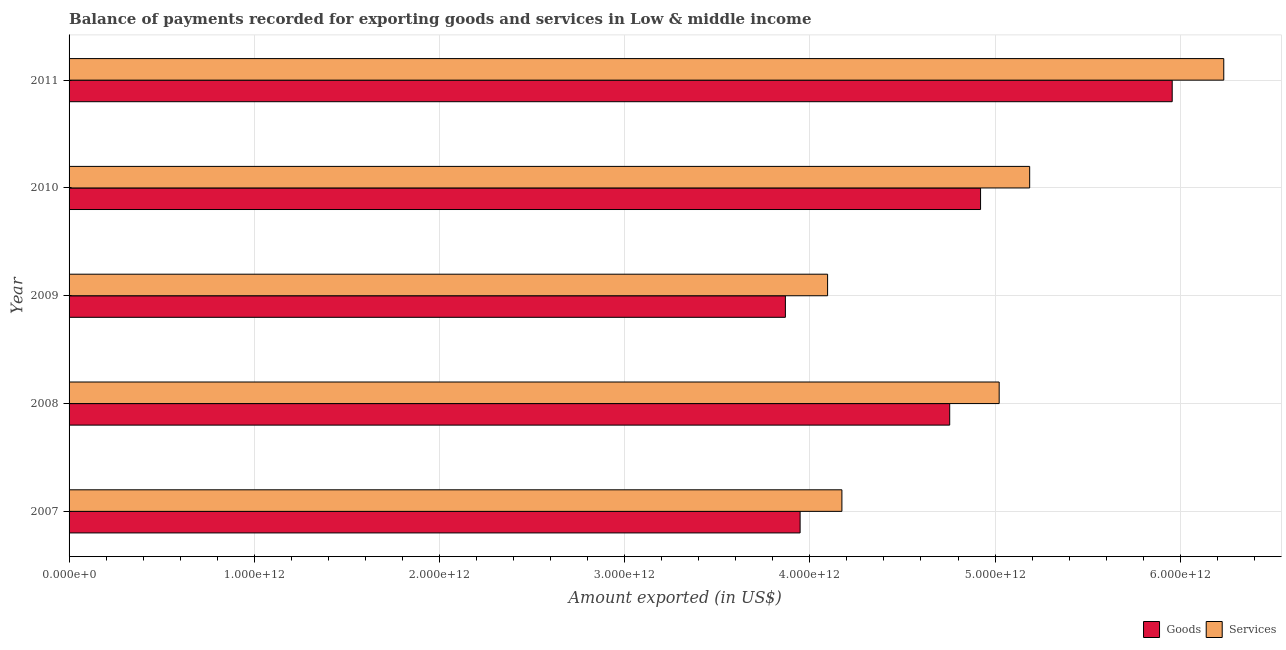How many different coloured bars are there?
Keep it short and to the point. 2. How many groups of bars are there?
Give a very brief answer. 5. Are the number of bars per tick equal to the number of legend labels?
Provide a short and direct response. Yes. Are the number of bars on each tick of the Y-axis equal?
Provide a short and direct response. Yes. How many bars are there on the 3rd tick from the top?
Provide a succinct answer. 2. How many bars are there on the 1st tick from the bottom?
Your answer should be compact. 2. In how many cases, is the number of bars for a given year not equal to the number of legend labels?
Your answer should be compact. 0. What is the amount of goods exported in 2011?
Provide a short and direct response. 5.96e+12. Across all years, what is the maximum amount of goods exported?
Provide a short and direct response. 5.96e+12. Across all years, what is the minimum amount of services exported?
Give a very brief answer. 4.10e+12. What is the total amount of goods exported in the graph?
Keep it short and to the point. 2.34e+13. What is the difference between the amount of services exported in 2007 and that in 2010?
Ensure brevity in your answer.  -1.01e+12. What is the difference between the amount of services exported in 2009 and the amount of goods exported in 2010?
Keep it short and to the point. -8.26e+11. What is the average amount of services exported per year?
Offer a very short reply. 4.94e+12. In the year 2007, what is the difference between the amount of services exported and amount of goods exported?
Give a very brief answer. 2.26e+11. What is the ratio of the amount of goods exported in 2009 to that in 2010?
Your answer should be very brief. 0.79. What is the difference between the highest and the second highest amount of services exported?
Your answer should be very brief. 1.05e+12. What is the difference between the highest and the lowest amount of services exported?
Keep it short and to the point. 2.14e+12. In how many years, is the amount of goods exported greater than the average amount of goods exported taken over all years?
Ensure brevity in your answer.  3. Is the sum of the amount of services exported in 2007 and 2010 greater than the maximum amount of goods exported across all years?
Your answer should be compact. Yes. What does the 1st bar from the top in 2010 represents?
Ensure brevity in your answer.  Services. What does the 1st bar from the bottom in 2010 represents?
Provide a succinct answer. Goods. Are all the bars in the graph horizontal?
Provide a succinct answer. Yes. How many years are there in the graph?
Your response must be concise. 5. What is the difference between two consecutive major ticks on the X-axis?
Provide a succinct answer. 1.00e+12. Does the graph contain grids?
Your response must be concise. Yes. Where does the legend appear in the graph?
Ensure brevity in your answer.  Bottom right. How are the legend labels stacked?
Provide a short and direct response. Horizontal. What is the title of the graph?
Ensure brevity in your answer.  Balance of payments recorded for exporting goods and services in Low & middle income. What is the label or title of the X-axis?
Provide a succinct answer. Amount exported (in US$). What is the label or title of the Y-axis?
Your answer should be compact. Year. What is the Amount exported (in US$) in Goods in 2007?
Offer a terse response. 3.95e+12. What is the Amount exported (in US$) in Services in 2007?
Make the answer very short. 4.17e+12. What is the Amount exported (in US$) in Goods in 2008?
Make the answer very short. 4.76e+12. What is the Amount exported (in US$) of Services in 2008?
Make the answer very short. 5.02e+12. What is the Amount exported (in US$) in Goods in 2009?
Make the answer very short. 3.87e+12. What is the Amount exported (in US$) of Services in 2009?
Offer a very short reply. 4.10e+12. What is the Amount exported (in US$) of Goods in 2010?
Offer a very short reply. 4.92e+12. What is the Amount exported (in US$) of Services in 2010?
Ensure brevity in your answer.  5.19e+12. What is the Amount exported (in US$) of Goods in 2011?
Your response must be concise. 5.96e+12. What is the Amount exported (in US$) of Services in 2011?
Your answer should be very brief. 6.23e+12. Across all years, what is the maximum Amount exported (in US$) in Goods?
Give a very brief answer. 5.96e+12. Across all years, what is the maximum Amount exported (in US$) in Services?
Ensure brevity in your answer.  6.23e+12. Across all years, what is the minimum Amount exported (in US$) in Goods?
Ensure brevity in your answer.  3.87e+12. Across all years, what is the minimum Amount exported (in US$) of Services?
Your response must be concise. 4.10e+12. What is the total Amount exported (in US$) in Goods in the graph?
Your answer should be very brief. 2.34e+13. What is the total Amount exported (in US$) of Services in the graph?
Provide a short and direct response. 2.47e+13. What is the difference between the Amount exported (in US$) in Goods in 2007 and that in 2008?
Make the answer very short. -8.08e+11. What is the difference between the Amount exported (in US$) in Services in 2007 and that in 2008?
Provide a succinct answer. -8.49e+11. What is the difference between the Amount exported (in US$) in Goods in 2007 and that in 2009?
Make the answer very short. 7.95e+1. What is the difference between the Amount exported (in US$) of Services in 2007 and that in 2009?
Your response must be concise. 7.73e+1. What is the difference between the Amount exported (in US$) in Goods in 2007 and that in 2010?
Make the answer very short. -9.74e+11. What is the difference between the Amount exported (in US$) in Services in 2007 and that in 2010?
Offer a very short reply. -1.01e+12. What is the difference between the Amount exported (in US$) of Goods in 2007 and that in 2011?
Offer a very short reply. -2.01e+12. What is the difference between the Amount exported (in US$) of Services in 2007 and that in 2011?
Offer a very short reply. -2.06e+12. What is the difference between the Amount exported (in US$) of Goods in 2008 and that in 2009?
Your answer should be compact. 8.87e+11. What is the difference between the Amount exported (in US$) in Services in 2008 and that in 2009?
Give a very brief answer. 9.27e+11. What is the difference between the Amount exported (in US$) of Goods in 2008 and that in 2010?
Your answer should be compact. -1.67e+11. What is the difference between the Amount exported (in US$) in Services in 2008 and that in 2010?
Give a very brief answer. -1.65e+11. What is the difference between the Amount exported (in US$) of Goods in 2008 and that in 2011?
Offer a terse response. -1.20e+12. What is the difference between the Amount exported (in US$) in Services in 2008 and that in 2011?
Give a very brief answer. -1.21e+12. What is the difference between the Amount exported (in US$) in Goods in 2009 and that in 2010?
Give a very brief answer. -1.05e+12. What is the difference between the Amount exported (in US$) in Services in 2009 and that in 2010?
Your answer should be compact. -1.09e+12. What is the difference between the Amount exported (in US$) in Goods in 2009 and that in 2011?
Offer a very short reply. -2.09e+12. What is the difference between the Amount exported (in US$) in Services in 2009 and that in 2011?
Ensure brevity in your answer.  -2.14e+12. What is the difference between the Amount exported (in US$) of Goods in 2010 and that in 2011?
Give a very brief answer. -1.03e+12. What is the difference between the Amount exported (in US$) of Services in 2010 and that in 2011?
Your answer should be very brief. -1.05e+12. What is the difference between the Amount exported (in US$) of Goods in 2007 and the Amount exported (in US$) of Services in 2008?
Keep it short and to the point. -1.07e+12. What is the difference between the Amount exported (in US$) in Goods in 2007 and the Amount exported (in US$) in Services in 2009?
Make the answer very short. -1.48e+11. What is the difference between the Amount exported (in US$) in Goods in 2007 and the Amount exported (in US$) in Services in 2010?
Offer a very short reply. -1.24e+12. What is the difference between the Amount exported (in US$) in Goods in 2007 and the Amount exported (in US$) in Services in 2011?
Provide a short and direct response. -2.29e+12. What is the difference between the Amount exported (in US$) in Goods in 2008 and the Amount exported (in US$) in Services in 2009?
Your response must be concise. 6.59e+11. What is the difference between the Amount exported (in US$) of Goods in 2008 and the Amount exported (in US$) of Services in 2010?
Your response must be concise. -4.32e+11. What is the difference between the Amount exported (in US$) in Goods in 2008 and the Amount exported (in US$) in Services in 2011?
Give a very brief answer. -1.48e+12. What is the difference between the Amount exported (in US$) of Goods in 2009 and the Amount exported (in US$) of Services in 2010?
Your answer should be very brief. -1.32e+12. What is the difference between the Amount exported (in US$) in Goods in 2009 and the Amount exported (in US$) in Services in 2011?
Provide a short and direct response. -2.37e+12. What is the difference between the Amount exported (in US$) in Goods in 2010 and the Amount exported (in US$) in Services in 2011?
Your response must be concise. -1.31e+12. What is the average Amount exported (in US$) of Goods per year?
Provide a succinct answer. 4.69e+12. What is the average Amount exported (in US$) of Services per year?
Provide a succinct answer. 4.94e+12. In the year 2007, what is the difference between the Amount exported (in US$) in Goods and Amount exported (in US$) in Services?
Provide a succinct answer. -2.26e+11. In the year 2008, what is the difference between the Amount exported (in US$) in Goods and Amount exported (in US$) in Services?
Your answer should be compact. -2.67e+11. In the year 2009, what is the difference between the Amount exported (in US$) in Goods and Amount exported (in US$) in Services?
Keep it short and to the point. -2.28e+11. In the year 2010, what is the difference between the Amount exported (in US$) in Goods and Amount exported (in US$) in Services?
Your answer should be very brief. -2.65e+11. In the year 2011, what is the difference between the Amount exported (in US$) in Goods and Amount exported (in US$) in Services?
Give a very brief answer. -2.78e+11. What is the ratio of the Amount exported (in US$) in Goods in 2007 to that in 2008?
Offer a terse response. 0.83. What is the ratio of the Amount exported (in US$) in Services in 2007 to that in 2008?
Keep it short and to the point. 0.83. What is the ratio of the Amount exported (in US$) in Goods in 2007 to that in 2009?
Your answer should be very brief. 1.02. What is the ratio of the Amount exported (in US$) of Services in 2007 to that in 2009?
Give a very brief answer. 1.02. What is the ratio of the Amount exported (in US$) in Goods in 2007 to that in 2010?
Your answer should be compact. 0.8. What is the ratio of the Amount exported (in US$) of Services in 2007 to that in 2010?
Offer a terse response. 0.8. What is the ratio of the Amount exported (in US$) in Goods in 2007 to that in 2011?
Your response must be concise. 0.66. What is the ratio of the Amount exported (in US$) of Services in 2007 to that in 2011?
Ensure brevity in your answer.  0.67. What is the ratio of the Amount exported (in US$) of Goods in 2008 to that in 2009?
Your answer should be compact. 1.23. What is the ratio of the Amount exported (in US$) in Services in 2008 to that in 2009?
Provide a short and direct response. 1.23. What is the ratio of the Amount exported (in US$) in Goods in 2008 to that in 2010?
Give a very brief answer. 0.97. What is the ratio of the Amount exported (in US$) of Services in 2008 to that in 2010?
Your answer should be very brief. 0.97. What is the ratio of the Amount exported (in US$) of Goods in 2008 to that in 2011?
Your answer should be very brief. 0.8. What is the ratio of the Amount exported (in US$) of Services in 2008 to that in 2011?
Your response must be concise. 0.81. What is the ratio of the Amount exported (in US$) of Goods in 2009 to that in 2010?
Your answer should be very brief. 0.79. What is the ratio of the Amount exported (in US$) of Services in 2009 to that in 2010?
Your response must be concise. 0.79. What is the ratio of the Amount exported (in US$) of Goods in 2009 to that in 2011?
Make the answer very short. 0.65. What is the ratio of the Amount exported (in US$) in Services in 2009 to that in 2011?
Ensure brevity in your answer.  0.66. What is the ratio of the Amount exported (in US$) of Goods in 2010 to that in 2011?
Give a very brief answer. 0.83. What is the ratio of the Amount exported (in US$) in Services in 2010 to that in 2011?
Your answer should be compact. 0.83. What is the difference between the highest and the second highest Amount exported (in US$) in Goods?
Your answer should be very brief. 1.03e+12. What is the difference between the highest and the second highest Amount exported (in US$) of Services?
Provide a succinct answer. 1.05e+12. What is the difference between the highest and the lowest Amount exported (in US$) of Goods?
Provide a short and direct response. 2.09e+12. What is the difference between the highest and the lowest Amount exported (in US$) of Services?
Your answer should be very brief. 2.14e+12. 